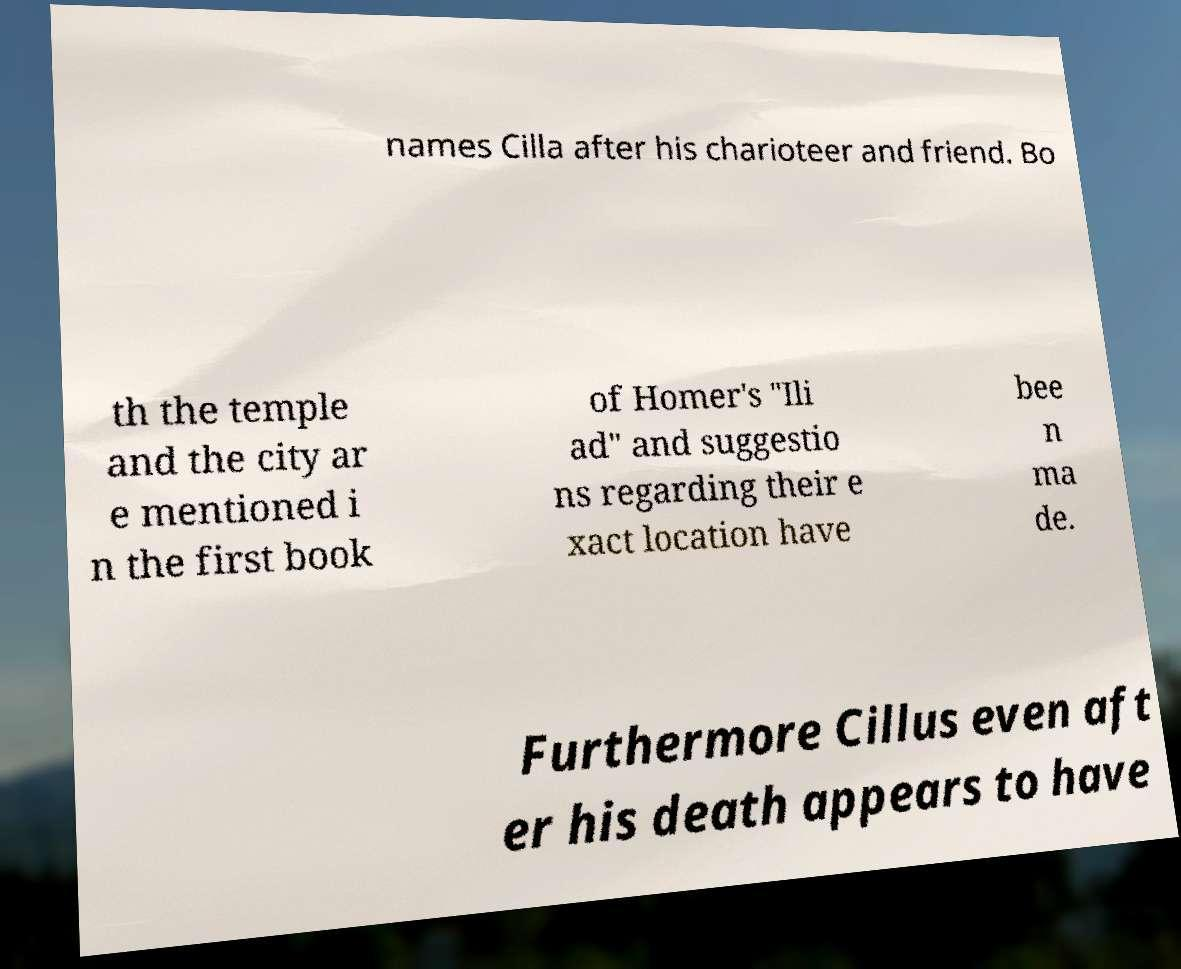For documentation purposes, I need the text within this image transcribed. Could you provide that? names Cilla after his charioteer and friend. Bo th the temple and the city ar e mentioned i n the first book of Homer's "Ili ad" and suggestio ns regarding their e xact location have bee n ma de. Furthermore Cillus even aft er his death appears to have 